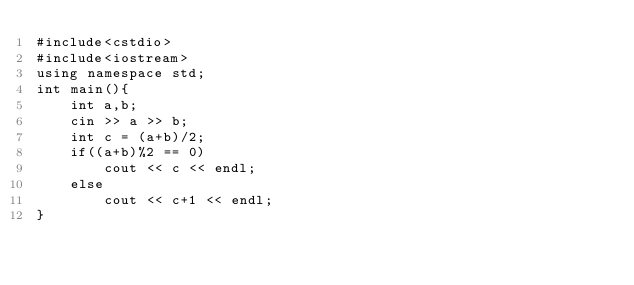<code> <loc_0><loc_0><loc_500><loc_500><_C++_>#include<cstdio>
#include<iostream>
using namespace std;
int main(){
	int a,b;
	cin >> a >> b;
	int c = (a+b)/2;
	if((a+b)%2 == 0)
		cout << c << endl;
	else 
		cout << c+1 << endl;
}</code> 